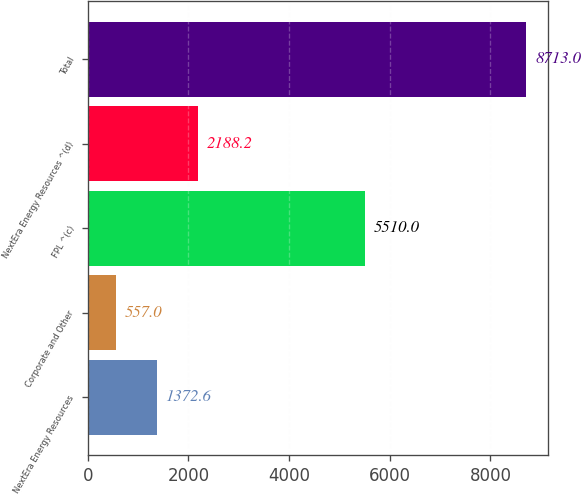<chart> <loc_0><loc_0><loc_500><loc_500><bar_chart><fcel>NextEra Energy Resources<fcel>Corporate and Other<fcel>FPL ^(c)<fcel>NextEra Energy Resources ^(d)<fcel>Total<nl><fcel>1372.6<fcel>557<fcel>5510<fcel>2188.2<fcel>8713<nl></chart> 